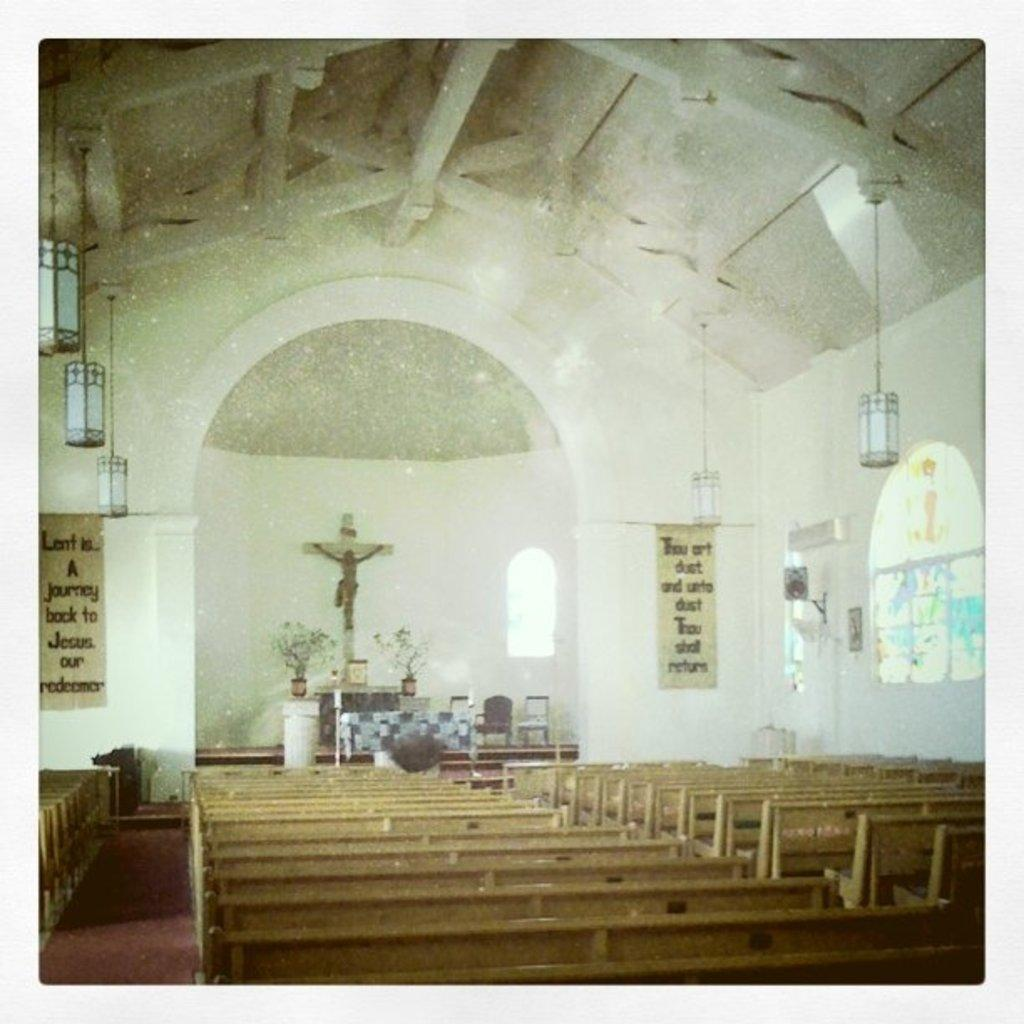What type of seating is visible in the image? There are benches in the image. Can you describe the setting of the image? The image appears to be the interior of a church. What type of sponge is used for cleaning the benches in the image? There is no sponge visible in the image, and it is not possible to determine what type of sponge might be used for cleaning the benches. 